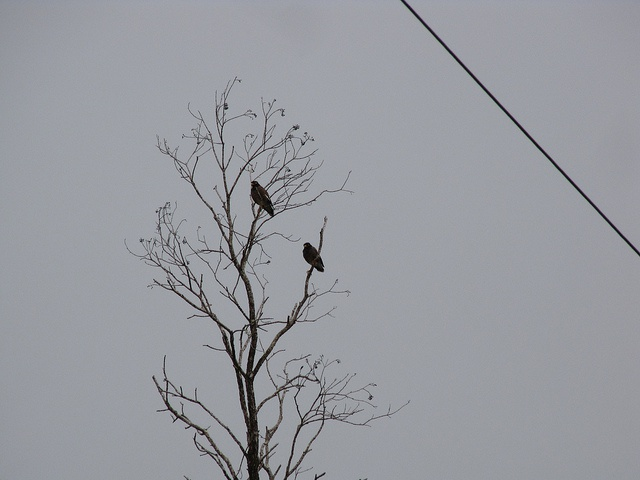Describe the objects in this image and their specific colors. I can see bird in gray, black, and darkgray tones and bird in gray, black, and darkgray tones in this image. 